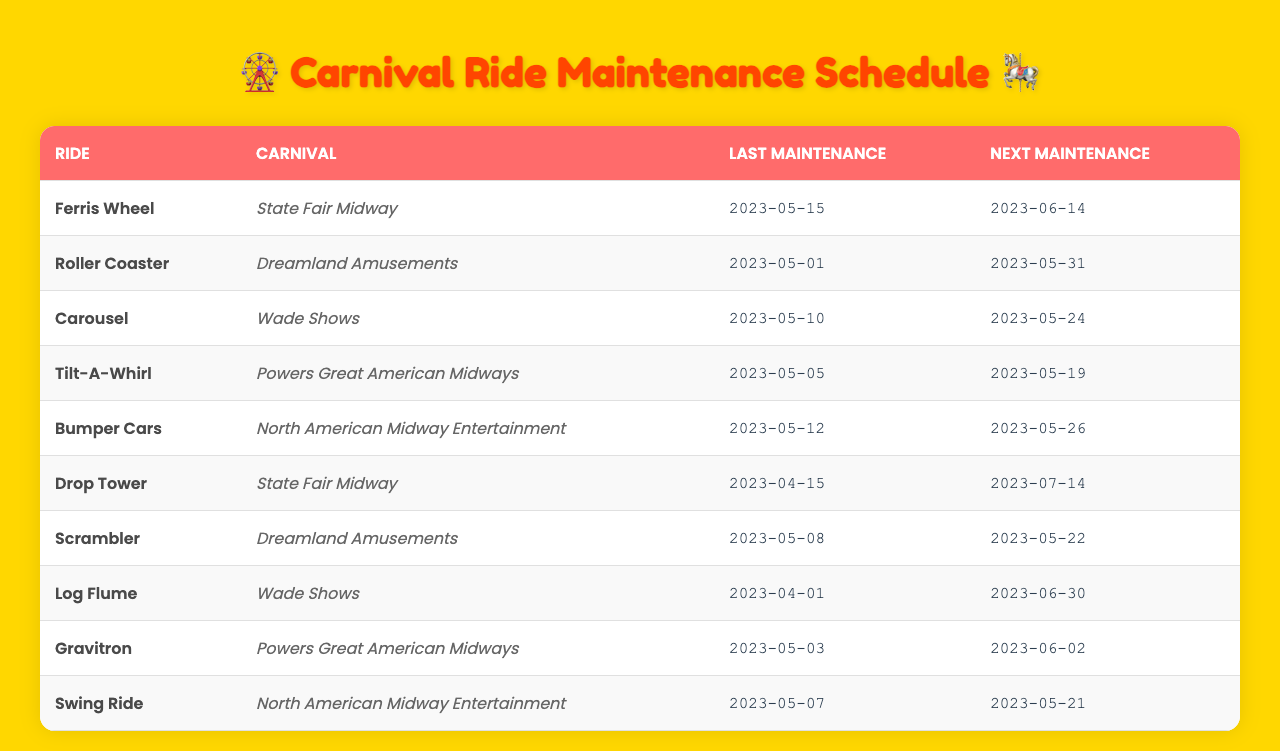What is the next maintenance date for the Bumper Cars? According to the table, the next maintenance date for the Bumper Cars is listed under the 'Next Maintenance' column, which is 2023-05-26.
Answer: 2023-05-26 Which carnival has the Ferris Wheel? The table indicates that the Ferris Wheel is associated with the State Fair Midway, as listed in the 'Carnival' column for the Ferris Wheel row.
Answer: State Fair Midway How many days are there between the last maintenance and next maintenance for the Roller Coaster? The last maintenance for the Roller Coaster was on 2023-05-01, and the next maintenance is on 2023-05-31. Calculating the difference gives 30 days.
Answer: 30 days Is there a ride that has a next maintenance date in June? Yes, both the Log Flume (next maintenance date 2023-06-30) and Gravitron (next maintenance date 2023-06-02) have their next maintenance scheduled in June.
Answer: Yes What is the average maintenance interval for the rides listed in the table? To find the average maintenance interval, sum the maintenance intervals listed (1 + 3 + 7 + 14 + 30 + 90 + 180 + 365 = 690) and divide by the total number of intervals (there are 8), resulting in an average of 86.25.
Answer: 86.25 Which carnival has the most rides scheduled for maintenance next? By examining the table, we find that the State Fair Midway has two rides scheduled for next maintenance: Ferris Wheel and Drop Tower. Thus, it has the most rides scheduled.
Answer: State Fair Midway When is the last maintenance for the Swing Ride? The table indicates that the last maintenance for the Swing Ride was on 2023-05-07, as noted under the 'Last Maintenance' column for that ride.
Answer: 2023-05-07 Which ride has the longest time until its next maintenance? The Drop Tower has its next maintenance scheduled on 2023-07-14, which is 90 days after the last maintenance on 2023-04-15, making it the longest interval until next maintenance.
Answer: Drop Tower Is every ride listed in the table scheduled for maintenance within the next month? No, the next maintenance dates vary with some rides, such as the Log Flume, having its next maintenance scheduled for 2023-06-30, well over a month from now.
Answer: No How many rides are scheduled for maintenance after May? The only ride scheduled for maintenance after May is the Log Flume, with next maintenance on 2023-06-30.
Answer: 1 